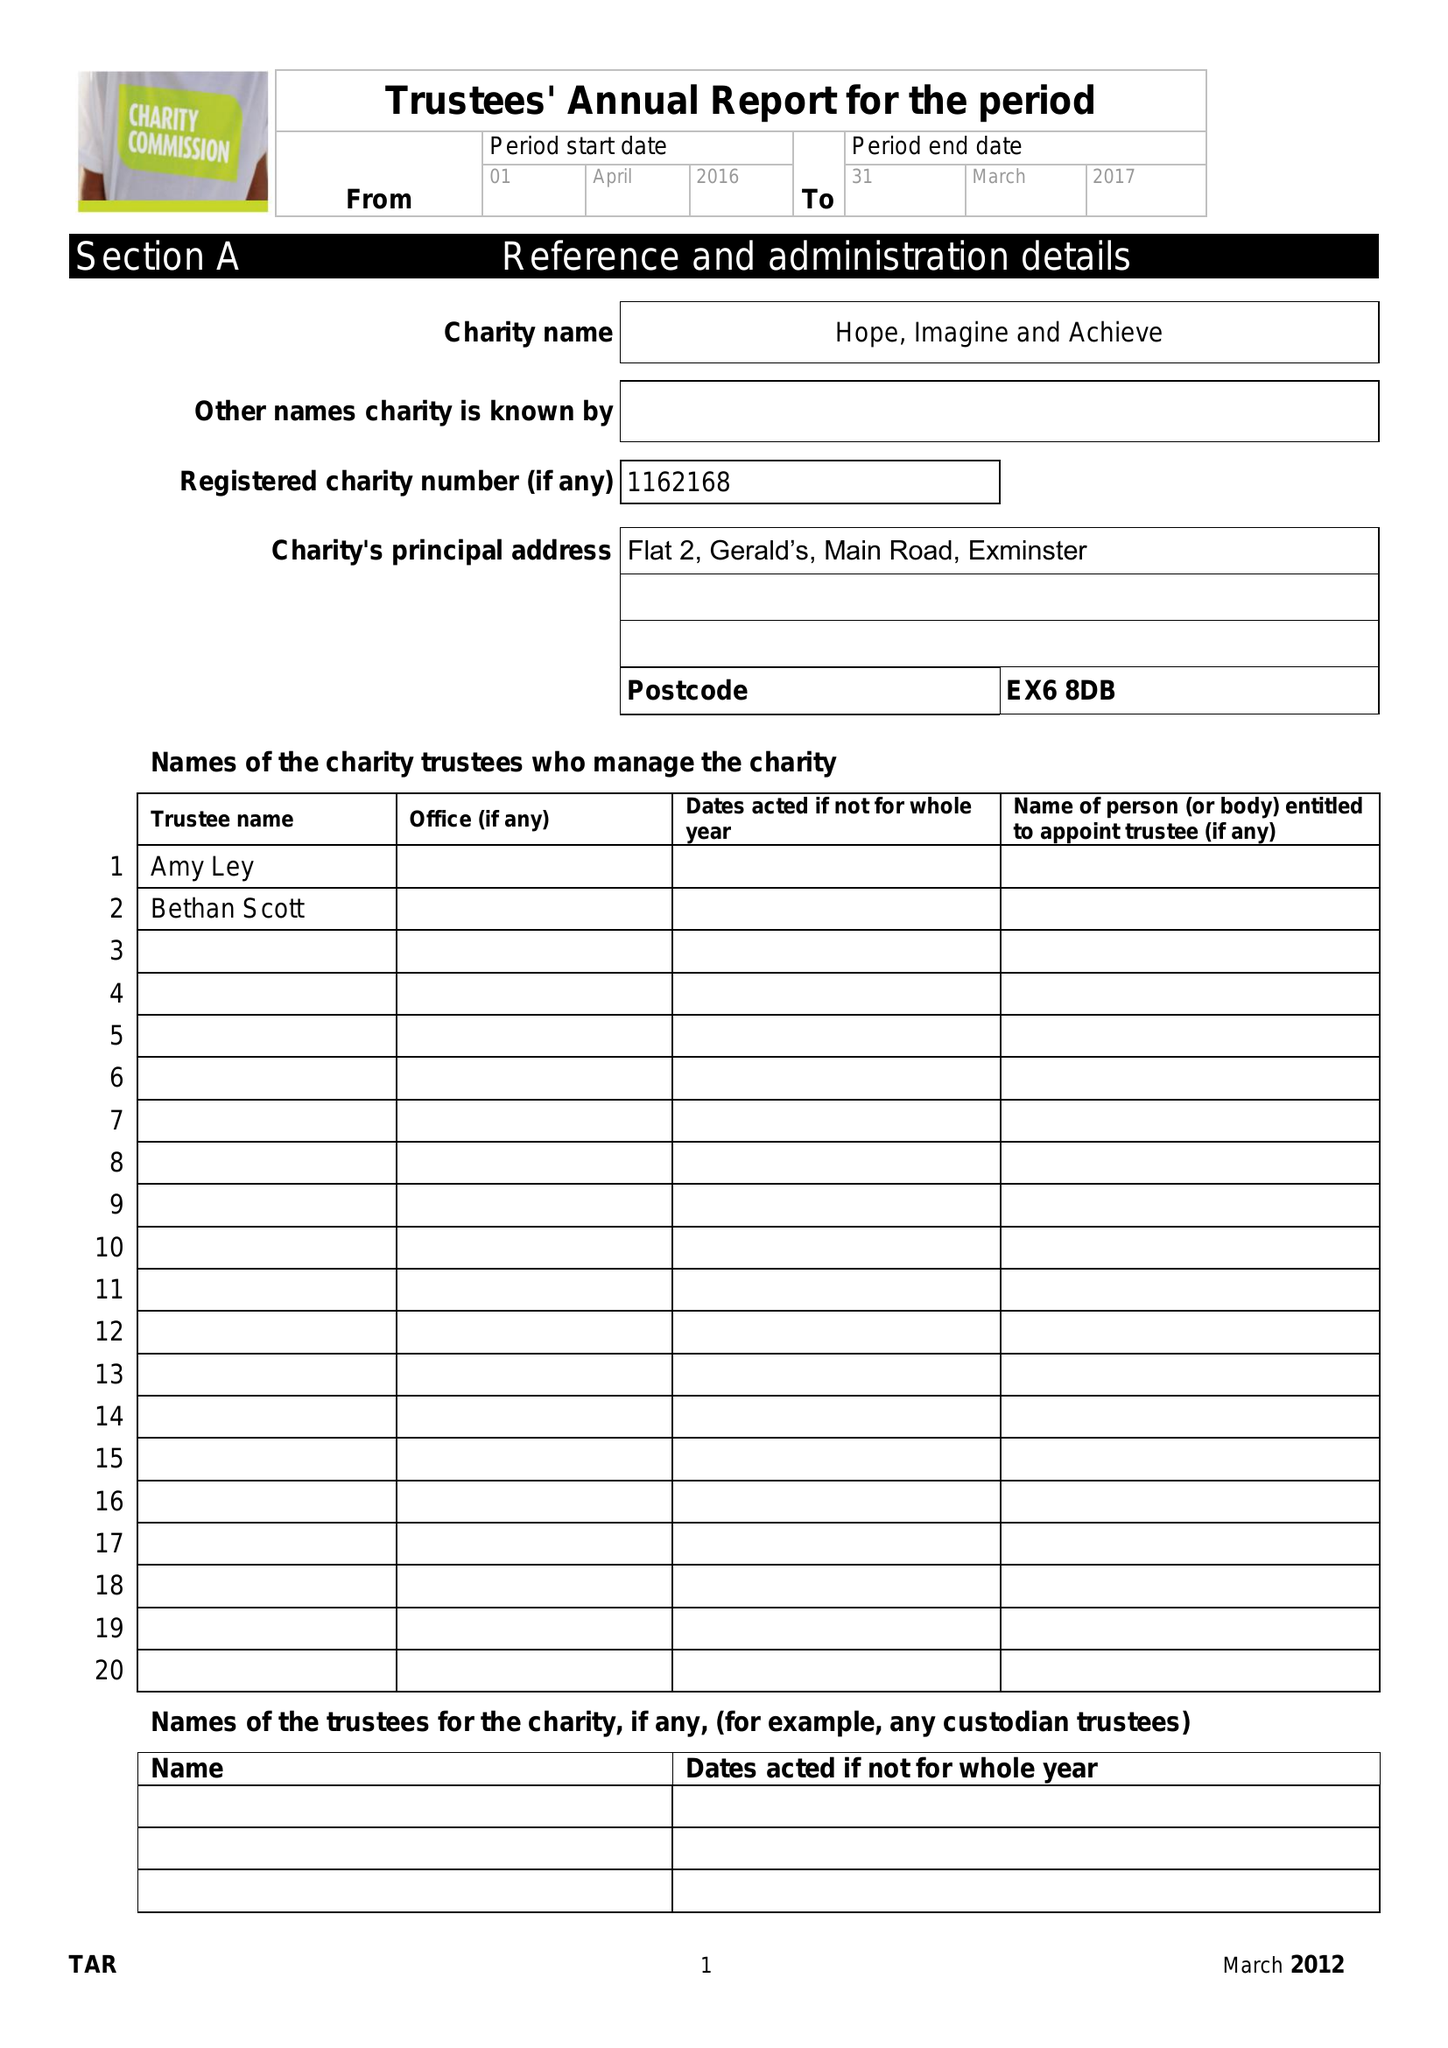What is the value for the charity_number?
Answer the question using a single word or phrase. 1162168 